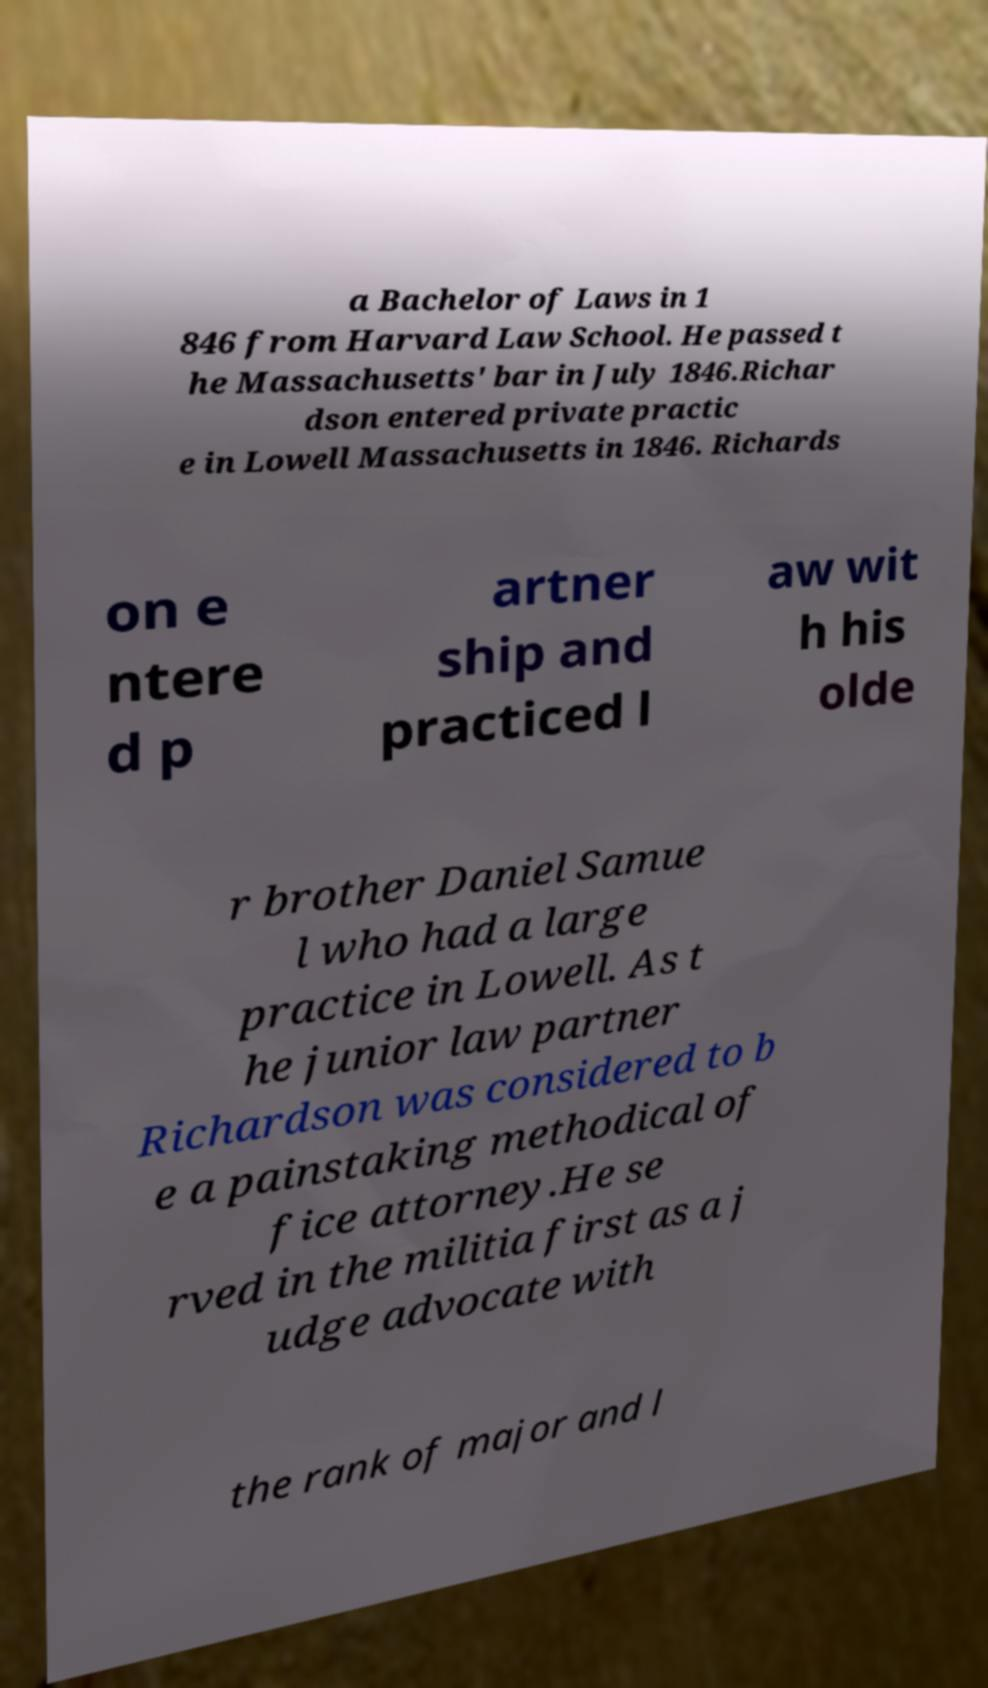For documentation purposes, I need the text within this image transcribed. Could you provide that? a Bachelor of Laws in 1 846 from Harvard Law School. He passed t he Massachusetts' bar in July 1846.Richar dson entered private practic e in Lowell Massachusetts in 1846. Richards on e ntere d p artner ship and practiced l aw wit h his olde r brother Daniel Samue l who had a large practice in Lowell. As t he junior law partner Richardson was considered to b e a painstaking methodical of fice attorney.He se rved in the militia first as a j udge advocate with the rank of major and l 